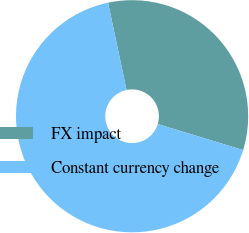<chart> <loc_0><loc_0><loc_500><loc_500><pie_chart><fcel>FX impact<fcel>Constant currency change<nl><fcel>33.03%<fcel>66.97%<nl></chart> 